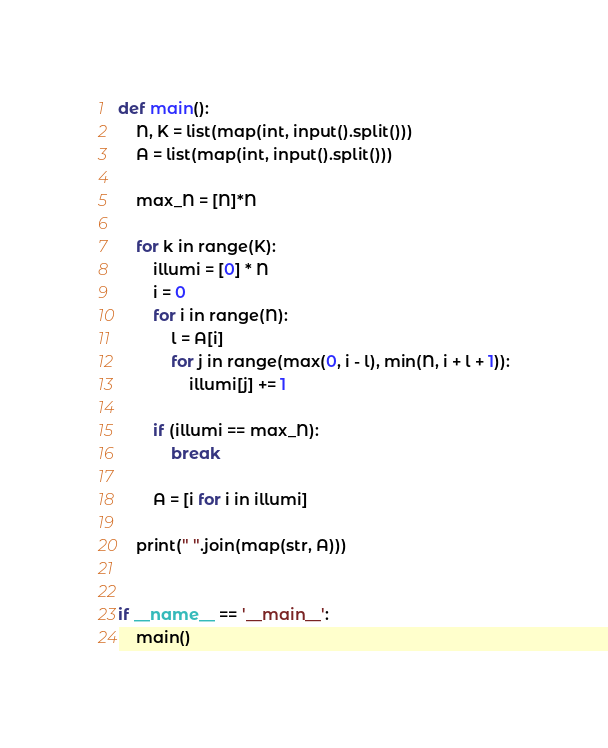<code> <loc_0><loc_0><loc_500><loc_500><_Python_>def main():
    N, K = list(map(int, input().split()))
    A = list(map(int, input().split()))

    max_N = [N]*N

    for k in range(K):
        illumi = [0] * N
        i = 0
        for i in range(N):
            l = A[i]
            for j in range(max(0, i - l), min(N, i + l + 1)):
                illumi[j] += 1

        if (illumi == max_N):
            break

        A = [i for i in illumi]

    print(" ".join(map(str, A)))


if __name__ == '__main__':
    main()
</code> 